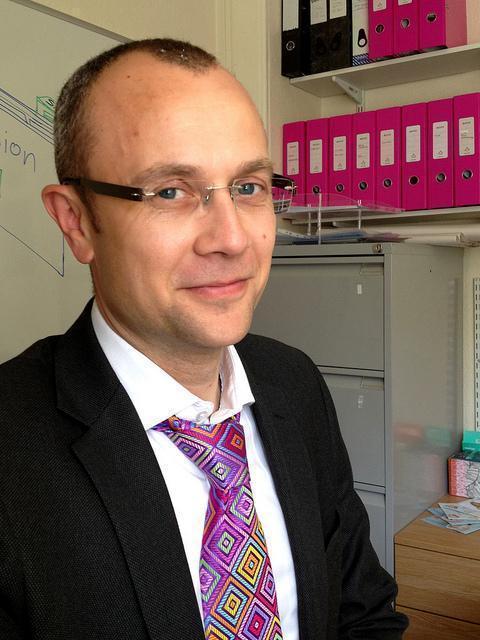What are the pink objects on the shelf?
Select the accurate response from the four choices given to answer the question.
Options: Boxes, envelopes, hard drives, binders. Binders. 